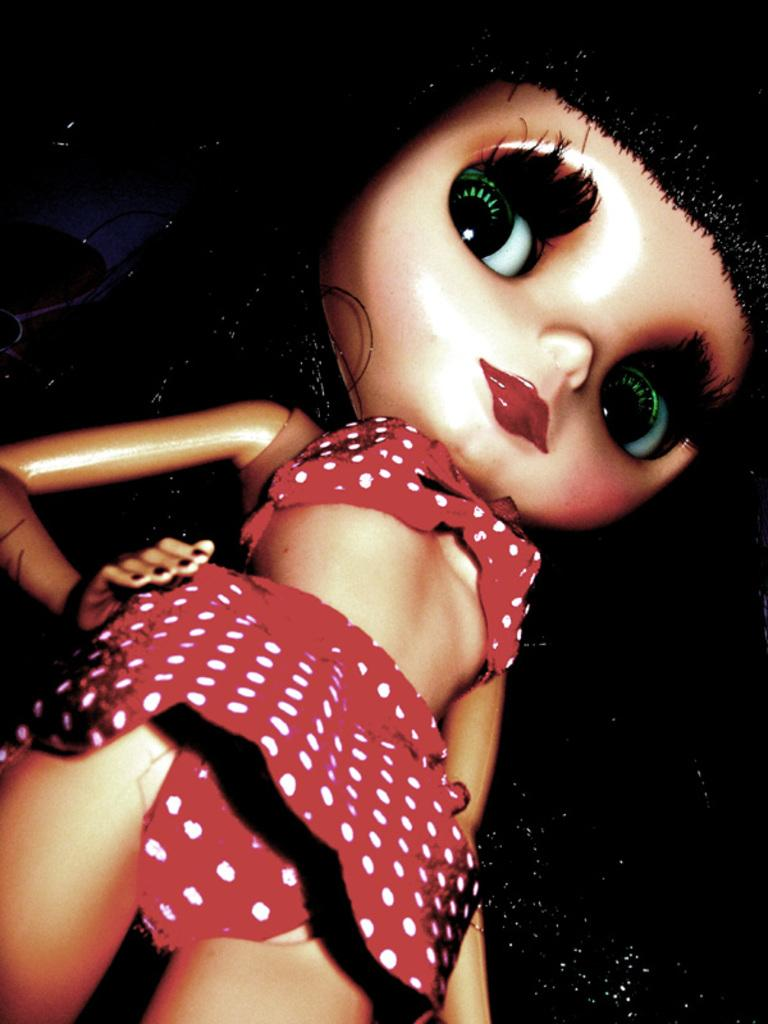What is the main subject of the picture? The main subject of the picture is a doll. What can be observed about the background of the image? The background of the image is dark. What type of crack is visible in the image? There is no crack present in the image; it features a doll against a dark background. What kind of reward is being given to the doll in the image? There is no reward being given to the doll in the image; it is a still image of a doll against a dark background. 